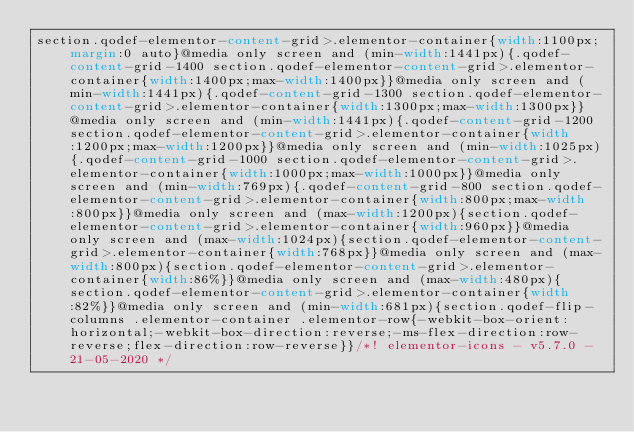Convert code to text. <code><loc_0><loc_0><loc_500><loc_500><_CSS_>section.qodef-elementor-content-grid>.elementor-container{width:1100px;margin:0 auto}@media only screen and (min-width:1441px){.qodef-content-grid-1400 section.qodef-elementor-content-grid>.elementor-container{width:1400px;max-width:1400px}}@media only screen and (min-width:1441px){.qodef-content-grid-1300 section.qodef-elementor-content-grid>.elementor-container{width:1300px;max-width:1300px}}@media only screen and (min-width:1441px){.qodef-content-grid-1200 section.qodef-elementor-content-grid>.elementor-container{width:1200px;max-width:1200px}}@media only screen and (min-width:1025px){.qodef-content-grid-1000 section.qodef-elementor-content-grid>.elementor-container{width:1000px;max-width:1000px}}@media only screen and (min-width:769px){.qodef-content-grid-800 section.qodef-elementor-content-grid>.elementor-container{width:800px;max-width:800px}}@media only screen and (max-width:1200px){section.qodef-elementor-content-grid>.elementor-container{width:960px}}@media only screen and (max-width:1024px){section.qodef-elementor-content-grid>.elementor-container{width:768px}}@media only screen and (max-width:800px){section.qodef-elementor-content-grid>.elementor-container{width:86%}}@media only screen and (max-width:480px){section.qodef-elementor-content-grid>.elementor-container{width:82%}}@media only screen and (min-width:681px){section.qodef-flip-columns .elementor-container .elementor-row{-webkit-box-orient:horizontal;-webkit-box-direction:reverse;-ms-flex-direction:row-reverse;flex-direction:row-reverse}}/*! elementor-icons - v5.7.0 - 21-05-2020 */</code> 